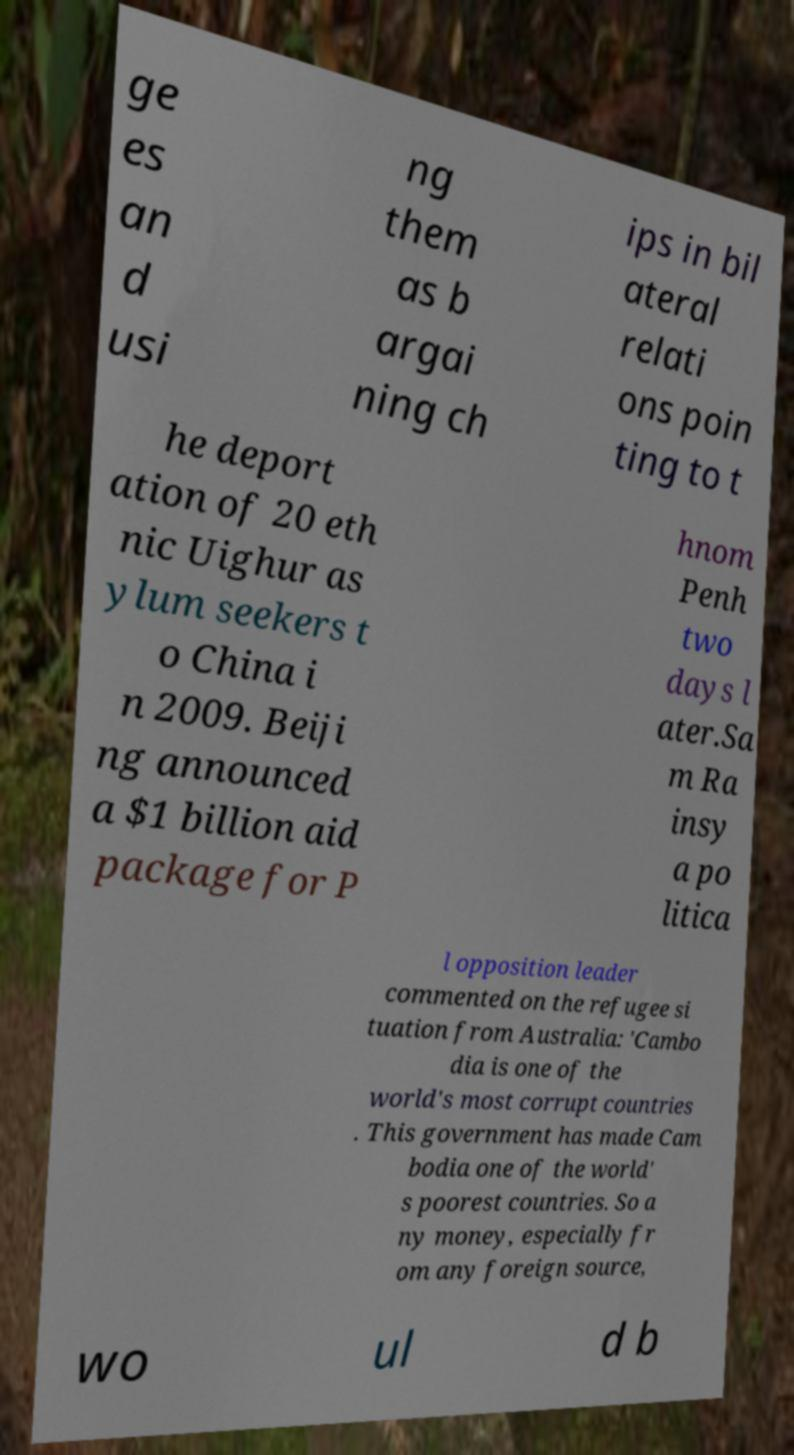Could you assist in decoding the text presented in this image and type it out clearly? ge es an d usi ng them as b argai ning ch ips in bil ateral relati ons poin ting to t he deport ation of 20 eth nic Uighur as ylum seekers t o China i n 2009. Beiji ng announced a $1 billion aid package for P hnom Penh two days l ater.Sa m Ra insy a po litica l opposition leader commented on the refugee si tuation from Australia: 'Cambo dia is one of the world's most corrupt countries . This government has made Cam bodia one of the world' s poorest countries. So a ny money, especially fr om any foreign source, wo ul d b 